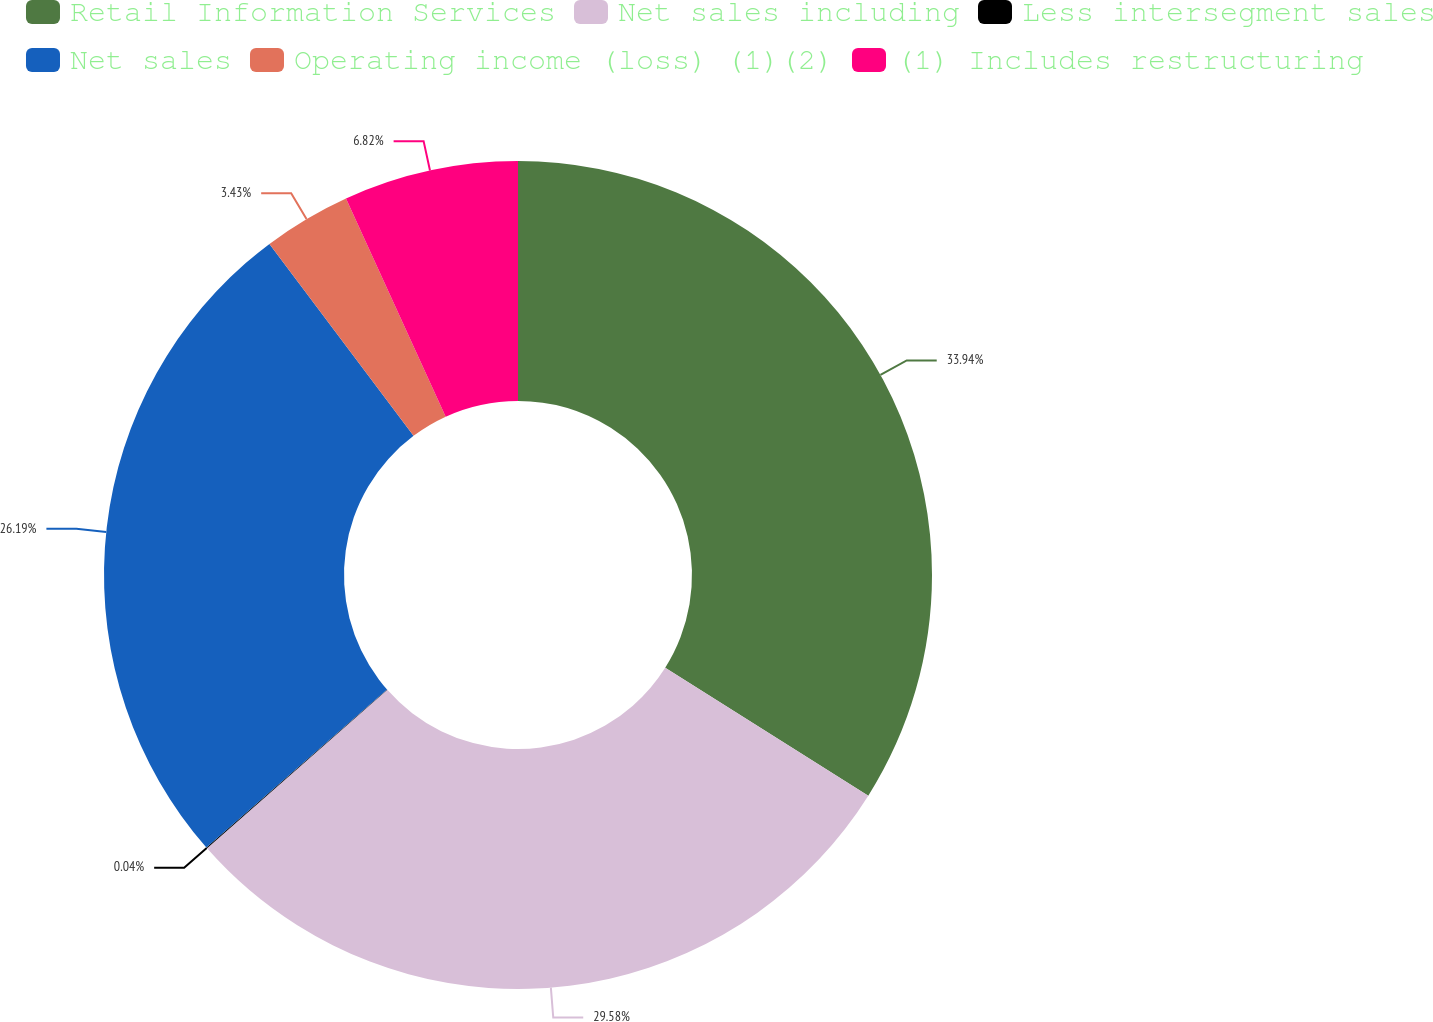<chart> <loc_0><loc_0><loc_500><loc_500><pie_chart><fcel>Retail Information Services<fcel>Net sales including<fcel>Less intersegment sales<fcel>Net sales<fcel>Operating income (loss) (1)(2)<fcel>(1) Includes restructuring<nl><fcel>33.95%<fcel>29.58%<fcel>0.04%<fcel>26.19%<fcel>3.43%<fcel>6.82%<nl></chart> 